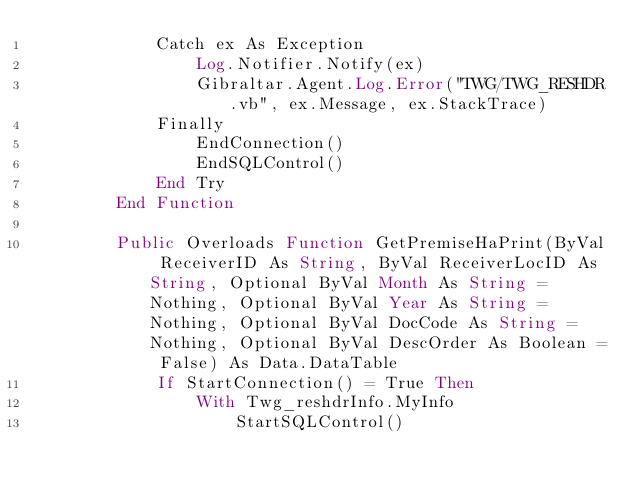Convert code to text. <code><loc_0><loc_0><loc_500><loc_500><_VisualBasic_>            Catch ex As Exception
                Log.Notifier.Notify(ex)
                Gibraltar.Agent.Log.Error("TWG/TWG_RESHDR.vb", ex.Message, ex.StackTrace)
            Finally
                EndConnection()
                EndSQLControl()
            End Try
        End Function

        Public Overloads Function GetPremiseHaPrint(ByVal ReceiverID As String, ByVal ReceiverLocID As String, Optional ByVal Month As String = Nothing, Optional ByVal Year As String = Nothing, Optional ByVal DocCode As String = Nothing, Optional ByVal DescOrder As Boolean = False) As Data.DataTable
            If StartConnection() = True Then
                With Twg_reshdrInfo.MyInfo
                    StartSQLControl()
</code> 